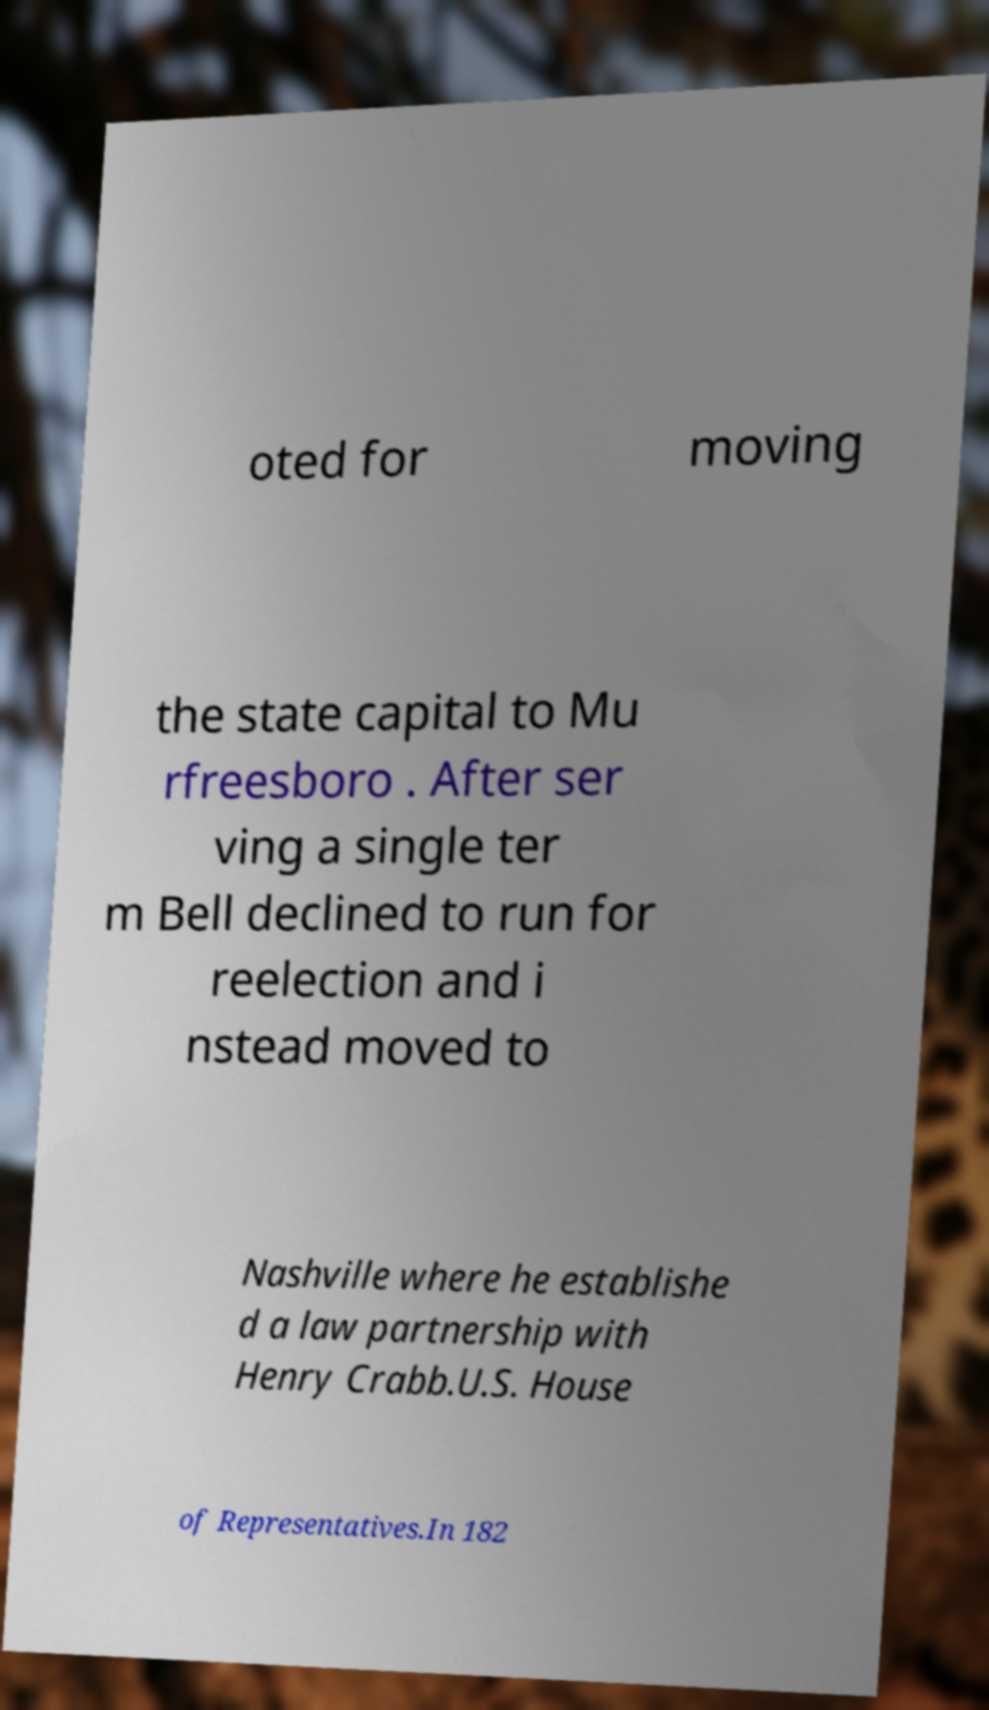Please identify and transcribe the text found in this image. oted for moving the state capital to Mu rfreesboro . After ser ving a single ter m Bell declined to run for reelection and i nstead moved to Nashville where he establishe d a law partnership with Henry Crabb.U.S. House of Representatives.In 182 